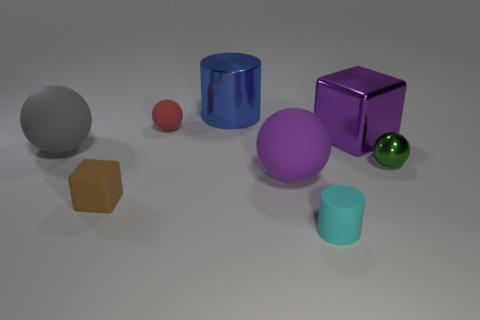Add 1 tiny balls. How many objects exist? 9 Subtract all red spheres. How many spheres are left? 3 Subtract 2 cylinders. How many cylinders are left? 0 Subtract all cyan cylinders. How many cylinders are left? 1 Subtract 0 yellow blocks. How many objects are left? 8 Subtract all cubes. How many objects are left? 6 Subtract all red cubes. Subtract all green cylinders. How many cubes are left? 2 Subtract all brown spheres. How many yellow cylinders are left? 0 Subtract all large cylinders. Subtract all cyan rubber cylinders. How many objects are left? 6 Add 4 big cubes. How many big cubes are left? 5 